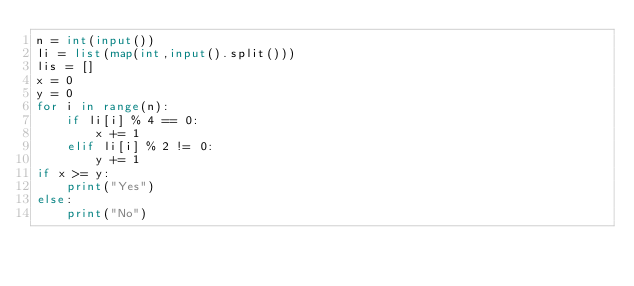Convert code to text. <code><loc_0><loc_0><loc_500><loc_500><_Python_>n = int(input())
li = list(map(int,input().split()))
lis = []
x = 0
y = 0
for i in range(n):
    if li[i] % 4 == 0:
        x += 1
    elif li[i] % 2 != 0:
        y += 1
if x >= y:
    print("Yes")
else:
    print("No")</code> 